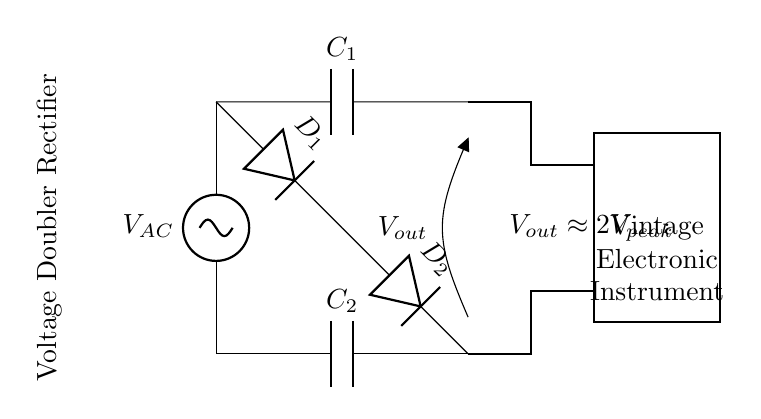What type of circuit is shown? The circuit is identified as a voltage doubler rectifier, as indicated in the annotation within the diagram. The configuration utilizes diodes and capacitors to double the input voltage.
Answer: Voltage doubler rectifier What are the components used in this circuit? The circuit includes two capacitors (C1 and C2) and two diodes (D1 and D2). These components are essential for the functioning of the voltage doubler configuration.
Answer: Capacitors and diodes What is the output voltage expression? The output voltage is approximately twice the peak voltage of the input AC source, as noted in the diagram. This implies that the circuit is designed to provide a higher DC voltage.
Answer: 2V peak How many diodes are present in the circuit? The diagram depicts two diodes, which are labeled as D1 and D2. Their arrangement is critical in allowing current to flow in a specific direction, thus contributing to the rectification process.
Answer: Two What happens to the output voltage as the input AC voltage increases? As the input AC voltage increases, the output voltage also increases, specifically maintaining the relationship of approximately twice the peak input voltage. This behavior highlights the circuit's functionality as a voltage doubler.
Answer: It increases What is the role of capacitors in this circuit? Capacitors C1 and C2 act as energy storage elements, charging during specific phases of the AC cycle and discharging to provide a stable DC output. Their placement in the circuit contributes to the smoothness of the output waveform.
Answer: Energy storage What type of devices can be powered by this circuit? The output of this voltage doubler rectifier circuit is suitable for powering vintage electronic musical instruments, as stated in the diagram. This means the circuit is designed specifically to meet the voltage requirements of such devices.
Answer: Vintage electronic musical instruments 